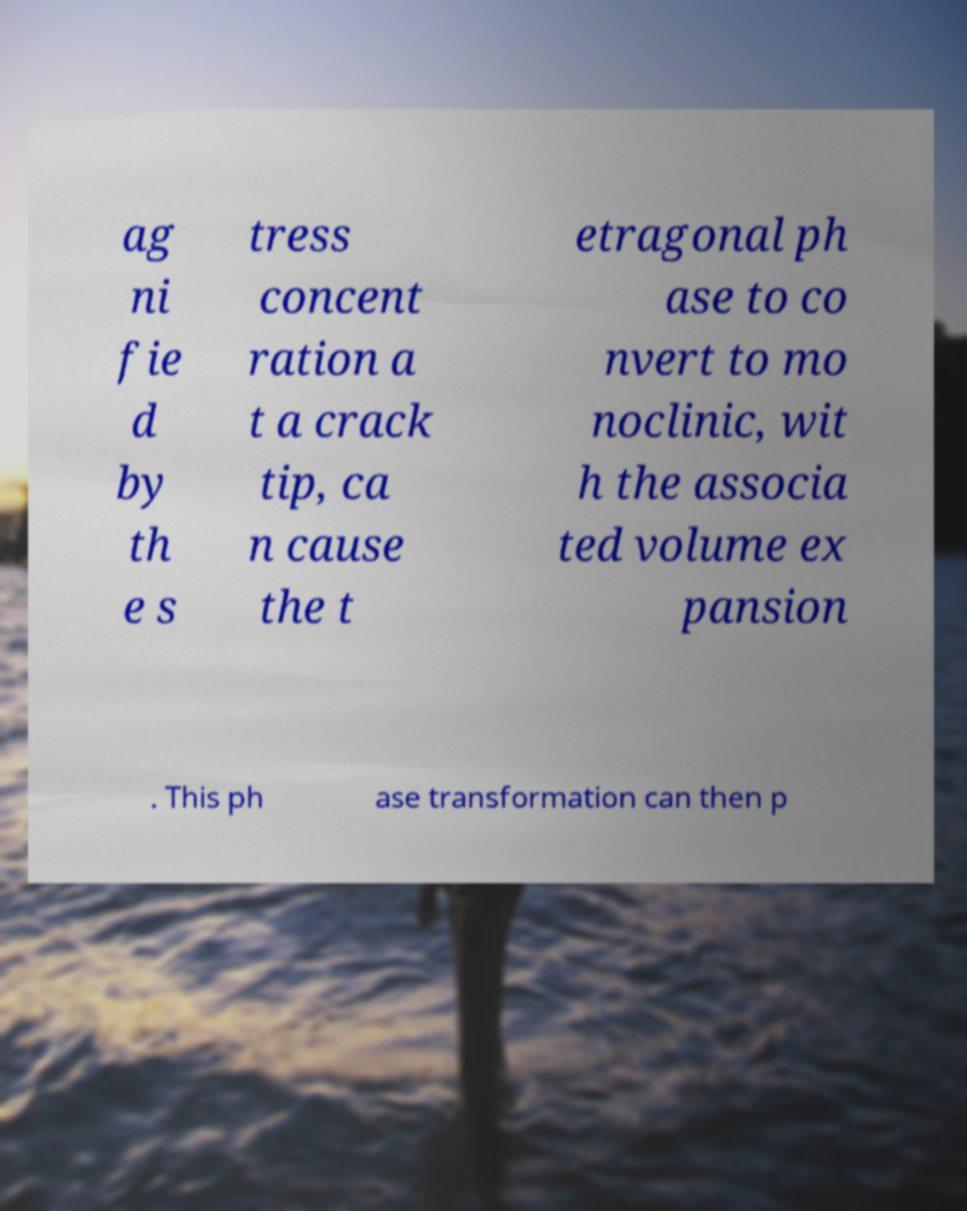What messages or text are displayed in this image? I need them in a readable, typed format. ag ni fie d by th e s tress concent ration a t a crack tip, ca n cause the t etragonal ph ase to co nvert to mo noclinic, wit h the associa ted volume ex pansion . This ph ase transformation can then p 